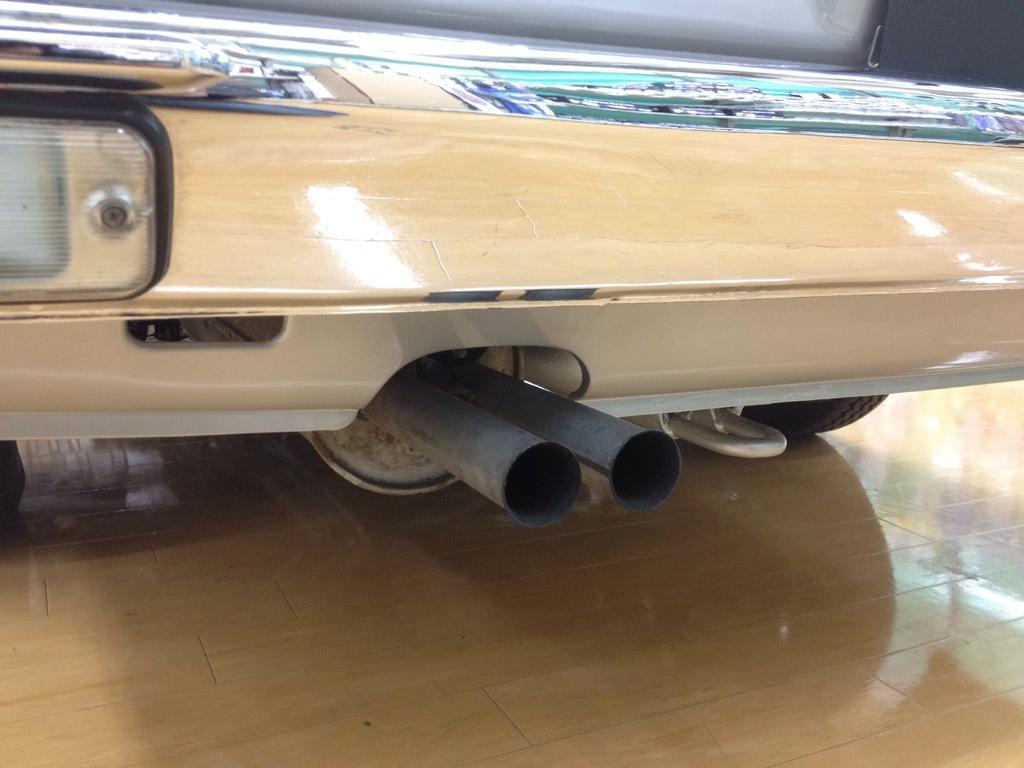What is the location of the image in relation to the vehicle? The image is taken at the backside of a vehicle. What can be seen in the center of the image? There are two tubes in the center of the image. What type of boundary can be seen in the image? There is no boundary visible in the image; it features the backside of a vehicle and two tubes. Can you describe the ghost in the image? There is no ghost present in the image. 